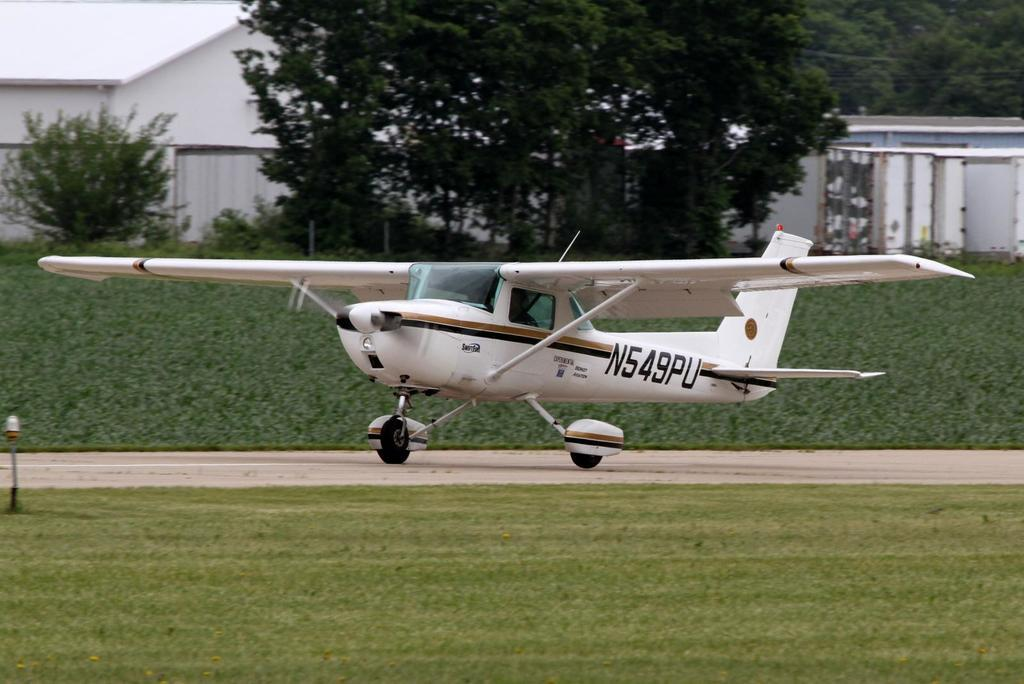Provide a one-sentence caption for the provided image. A small white plane is on the ground with SWIFTFUEL EXPERIMENTAL BOUNTY AVIATION N549PU in it. 